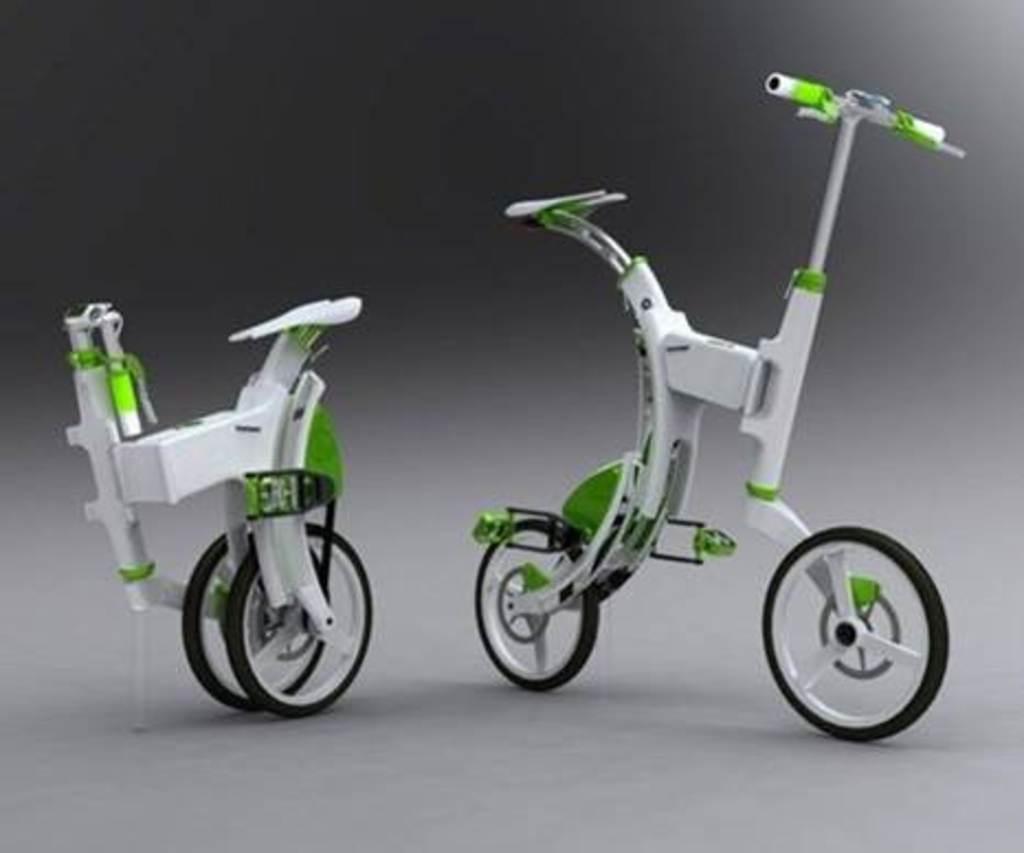How would you summarize this image in a sentence or two? In this picture we can see the toy bicycles are present on the surface. 